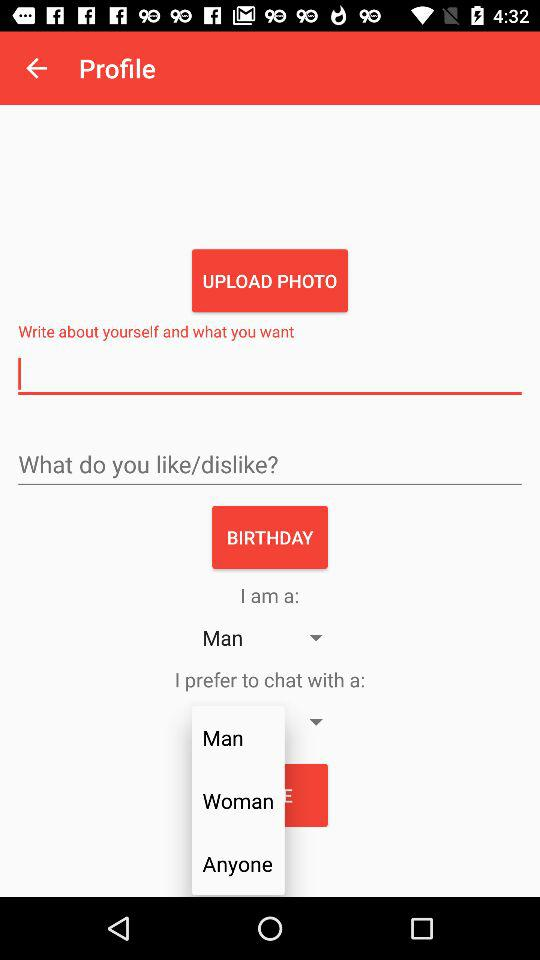Which option is selected for "I am a"? The selected option is "Man". 